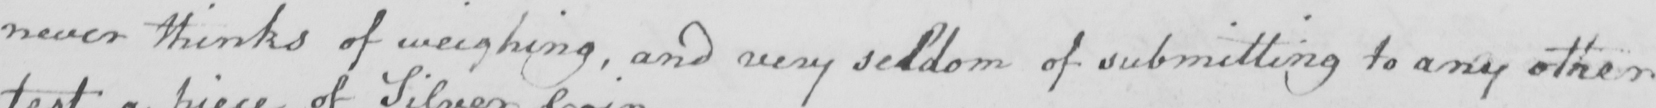What is written in this line of handwriting? never thinks of weighing , and very seldom of submitting to any other 